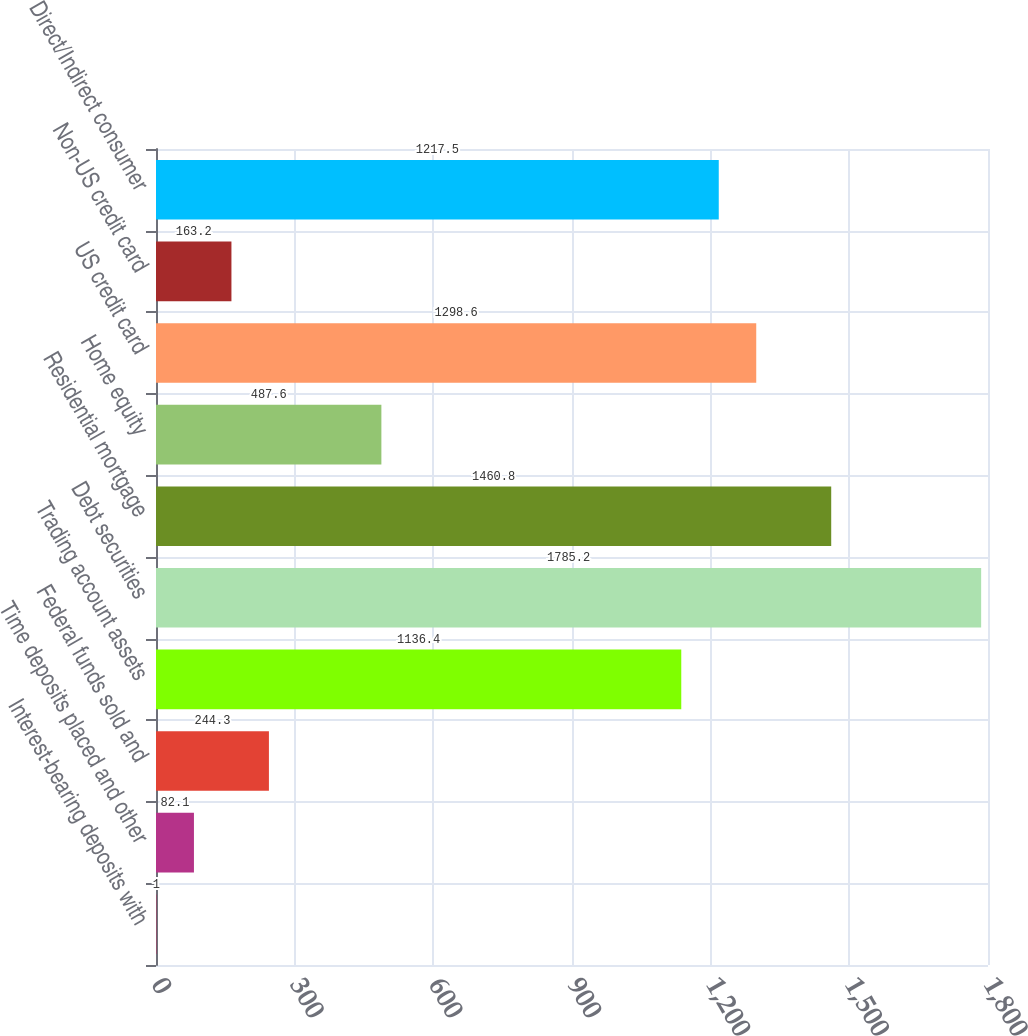Convert chart. <chart><loc_0><loc_0><loc_500><loc_500><bar_chart><fcel>Interest-bearing deposits with<fcel>Time deposits placed and other<fcel>Federal funds sold and<fcel>Trading account assets<fcel>Debt securities<fcel>Residential mortgage<fcel>Home equity<fcel>US credit card<fcel>Non-US credit card<fcel>Direct/Indirect consumer<nl><fcel>1<fcel>82.1<fcel>244.3<fcel>1136.4<fcel>1785.2<fcel>1460.8<fcel>487.6<fcel>1298.6<fcel>163.2<fcel>1217.5<nl></chart> 